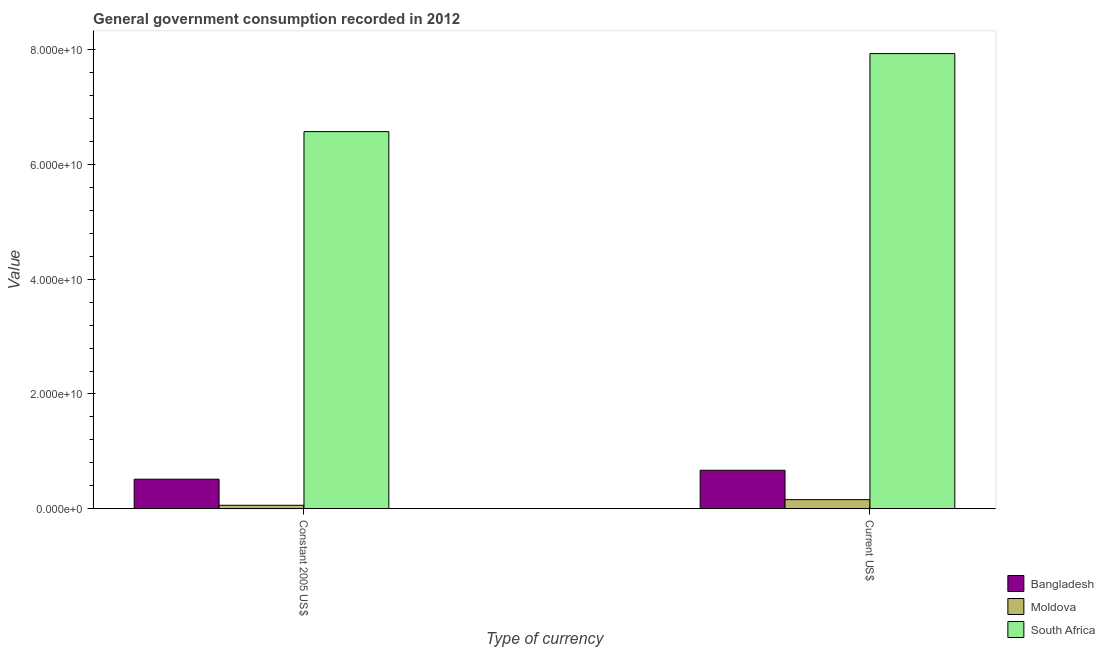How many different coloured bars are there?
Your answer should be compact. 3. Are the number of bars per tick equal to the number of legend labels?
Provide a short and direct response. Yes. Are the number of bars on each tick of the X-axis equal?
Offer a very short reply. Yes. What is the label of the 1st group of bars from the left?
Make the answer very short. Constant 2005 US$. What is the value consumed in current us$ in South Africa?
Your answer should be compact. 7.93e+1. Across all countries, what is the maximum value consumed in current us$?
Your answer should be very brief. 7.93e+1. Across all countries, what is the minimum value consumed in constant 2005 us$?
Offer a terse response. 6.22e+08. In which country was the value consumed in constant 2005 us$ maximum?
Your response must be concise. South Africa. In which country was the value consumed in constant 2005 us$ minimum?
Your answer should be compact. Moldova. What is the total value consumed in current us$ in the graph?
Offer a terse response. 8.76e+1. What is the difference between the value consumed in current us$ in Moldova and that in Bangladesh?
Ensure brevity in your answer.  -5.12e+09. What is the difference between the value consumed in constant 2005 us$ in South Africa and the value consumed in current us$ in Moldova?
Your response must be concise. 6.41e+1. What is the average value consumed in current us$ per country?
Give a very brief answer. 2.92e+1. What is the difference between the value consumed in current us$ and value consumed in constant 2005 us$ in Bangladesh?
Provide a short and direct response. 1.56e+09. What is the ratio of the value consumed in constant 2005 us$ in South Africa to that in Bangladesh?
Provide a short and direct response. 12.73. Is the value consumed in current us$ in South Africa less than that in Bangladesh?
Give a very brief answer. No. In how many countries, is the value consumed in current us$ greater than the average value consumed in current us$ taken over all countries?
Make the answer very short. 1. What does the 3rd bar from the right in Constant 2005 US$ represents?
Give a very brief answer. Bangladesh. How many bars are there?
Keep it short and to the point. 6. Are all the bars in the graph horizontal?
Keep it short and to the point. No. How many countries are there in the graph?
Offer a terse response. 3. What is the difference between two consecutive major ticks on the Y-axis?
Your answer should be very brief. 2.00e+1. Are the values on the major ticks of Y-axis written in scientific E-notation?
Your answer should be very brief. Yes. Does the graph contain any zero values?
Provide a short and direct response. No. What is the title of the graph?
Give a very brief answer. General government consumption recorded in 2012. What is the label or title of the X-axis?
Your answer should be very brief. Type of currency. What is the label or title of the Y-axis?
Ensure brevity in your answer.  Value. What is the Value of Bangladesh in Constant 2005 US$?
Provide a short and direct response. 5.16e+09. What is the Value of Moldova in Constant 2005 US$?
Offer a terse response. 6.22e+08. What is the Value in South Africa in Constant 2005 US$?
Offer a terse response. 6.57e+1. What is the Value in Bangladesh in Current US$?
Provide a short and direct response. 6.72e+09. What is the Value in Moldova in Current US$?
Ensure brevity in your answer.  1.60e+09. What is the Value of South Africa in Current US$?
Ensure brevity in your answer.  7.93e+1. Across all Type of currency, what is the maximum Value of Bangladesh?
Provide a succinct answer. 6.72e+09. Across all Type of currency, what is the maximum Value in Moldova?
Offer a terse response. 1.60e+09. Across all Type of currency, what is the maximum Value of South Africa?
Your answer should be compact. 7.93e+1. Across all Type of currency, what is the minimum Value in Bangladesh?
Offer a terse response. 5.16e+09. Across all Type of currency, what is the minimum Value of Moldova?
Offer a very short reply. 6.22e+08. Across all Type of currency, what is the minimum Value in South Africa?
Keep it short and to the point. 6.57e+1. What is the total Value of Bangladesh in the graph?
Your answer should be compact. 1.19e+1. What is the total Value of Moldova in the graph?
Your response must be concise. 2.22e+09. What is the total Value in South Africa in the graph?
Your response must be concise. 1.45e+11. What is the difference between the Value of Bangladesh in Constant 2005 US$ and that in Current US$?
Provide a succinct answer. -1.56e+09. What is the difference between the Value in Moldova in Constant 2005 US$ and that in Current US$?
Provide a short and direct response. -9.80e+08. What is the difference between the Value in South Africa in Constant 2005 US$ and that in Current US$?
Make the answer very short. -1.36e+1. What is the difference between the Value of Bangladesh in Constant 2005 US$ and the Value of Moldova in Current US$?
Ensure brevity in your answer.  3.56e+09. What is the difference between the Value in Bangladesh in Constant 2005 US$ and the Value in South Africa in Current US$?
Provide a short and direct response. -7.41e+1. What is the difference between the Value of Moldova in Constant 2005 US$ and the Value of South Africa in Current US$?
Make the answer very short. -7.87e+1. What is the average Value of Bangladesh per Type of currency?
Your answer should be compact. 5.94e+09. What is the average Value of Moldova per Type of currency?
Your response must be concise. 1.11e+09. What is the average Value in South Africa per Type of currency?
Your response must be concise. 7.25e+1. What is the difference between the Value in Bangladesh and Value in Moldova in Constant 2005 US$?
Provide a succinct answer. 4.54e+09. What is the difference between the Value in Bangladesh and Value in South Africa in Constant 2005 US$?
Give a very brief answer. -6.05e+1. What is the difference between the Value of Moldova and Value of South Africa in Constant 2005 US$?
Your response must be concise. -6.51e+1. What is the difference between the Value in Bangladesh and Value in Moldova in Current US$?
Ensure brevity in your answer.  5.12e+09. What is the difference between the Value in Bangladesh and Value in South Africa in Current US$?
Offer a very short reply. -7.26e+1. What is the difference between the Value in Moldova and Value in South Africa in Current US$?
Your response must be concise. -7.77e+1. What is the ratio of the Value in Bangladesh in Constant 2005 US$ to that in Current US$?
Give a very brief answer. 0.77. What is the ratio of the Value of Moldova in Constant 2005 US$ to that in Current US$?
Provide a succinct answer. 0.39. What is the ratio of the Value in South Africa in Constant 2005 US$ to that in Current US$?
Provide a succinct answer. 0.83. What is the difference between the highest and the second highest Value of Bangladesh?
Keep it short and to the point. 1.56e+09. What is the difference between the highest and the second highest Value in Moldova?
Keep it short and to the point. 9.80e+08. What is the difference between the highest and the second highest Value of South Africa?
Your answer should be compact. 1.36e+1. What is the difference between the highest and the lowest Value in Bangladesh?
Provide a succinct answer. 1.56e+09. What is the difference between the highest and the lowest Value of Moldova?
Provide a short and direct response. 9.80e+08. What is the difference between the highest and the lowest Value in South Africa?
Your response must be concise. 1.36e+1. 